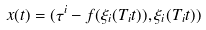Convert formula to latex. <formula><loc_0><loc_0><loc_500><loc_500>x ( t ) = ( \tau ^ { i } - f ( \xi _ { i } ( T _ { i } t ) ) , \xi _ { i } ( T _ { i } t ) )</formula> 